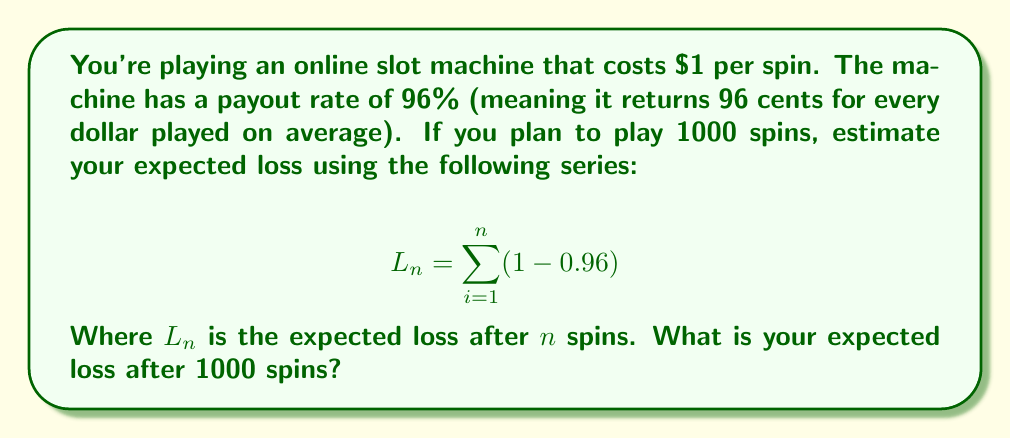Show me your answer to this math problem. To solve this problem, we need to understand the concept of expected value in gambling and how to sum a series.

1) First, let's break down the series:
   $L_n = \sum_{i=1}^n (1 - 0.96)$

   This series represents the expected loss on each spin. For each spin, you're expected to lose 4 cents (1 - 0.96 = 0.04).

2) The sum of this series from 1 to n is equivalent to multiplying (1 - 0.96) by n:
   $L_n = n(1 - 0.96) = 0.04n$

3) We're asked to calculate this for 1000 spins, so:
   $L_{1000} = 0.04 * 1000 = 40$

Therefore, after 1000 spins, your expected loss is $40.

This method uses the concept of expected value to estimate long-term profitability. While individual sessions may vary due to the random nature of gambling, over a large number of spins, your results should converge towards this expected value.
Answer: $40 